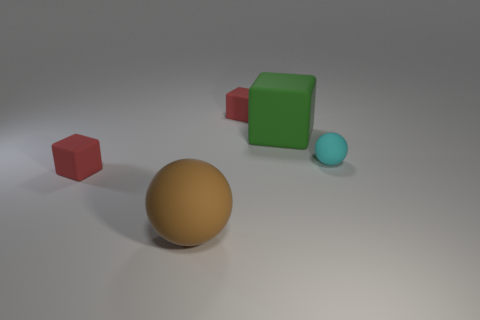What shape is the green rubber object?
Your answer should be very brief. Cube. There is a ball on the left side of the green thing; what is its color?
Your answer should be very brief. Brown. There is a cyan thing that is the same material as the large brown sphere; what is its shape?
Provide a short and direct response. Sphere. What number of other things are the same shape as the cyan matte thing?
Your response must be concise. 1. There is a tiny sphere; how many matte things are to the left of it?
Keep it short and to the point. 4. Do the rubber block that is in front of the tiny cyan sphere and the red cube that is behind the big green thing have the same size?
Provide a succinct answer. Yes. What number of other objects are there of the same size as the green rubber object?
Make the answer very short. 1. What material is the cube that is in front of the green rubber object behind the large brown object in front of the small cyan rubber ball?
Your answer should be very brief. Rubber. There is a cyan ball; is it the same size as the block that is in front of the tiny cyan sphere?
Keep it short and to the point. Yes. There is a small cube on the left side of the red block that is behind the green rubber block; what is its color?
Ensure brevity in your answer.  Red. 